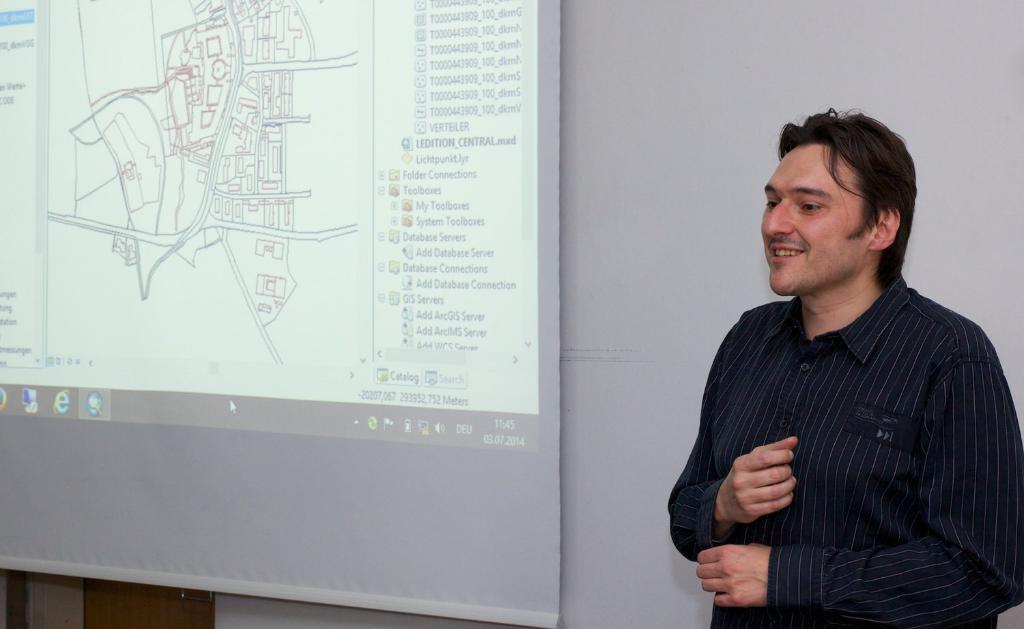What is the main subject of the image? There is a person standing in the image. Can you describe the person's attire? The person is wearing a black dress. What can be seen in the background of the image? There is a projector screen in the background of the image. What color is the wall behind the projector screen? The wall behind the projector screen is white. Can you see a hole in the dress that the person is wearing? There is no hole visible in the dress that the person is wearing. What type of lead is being used to connect the projector to the screen? There is no information about a lead or any connection between the projector and the screen in the image. 